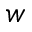Convert formula to latex. <formula><loc_0><loc_0><loc_500><loc_500>w</formula> 